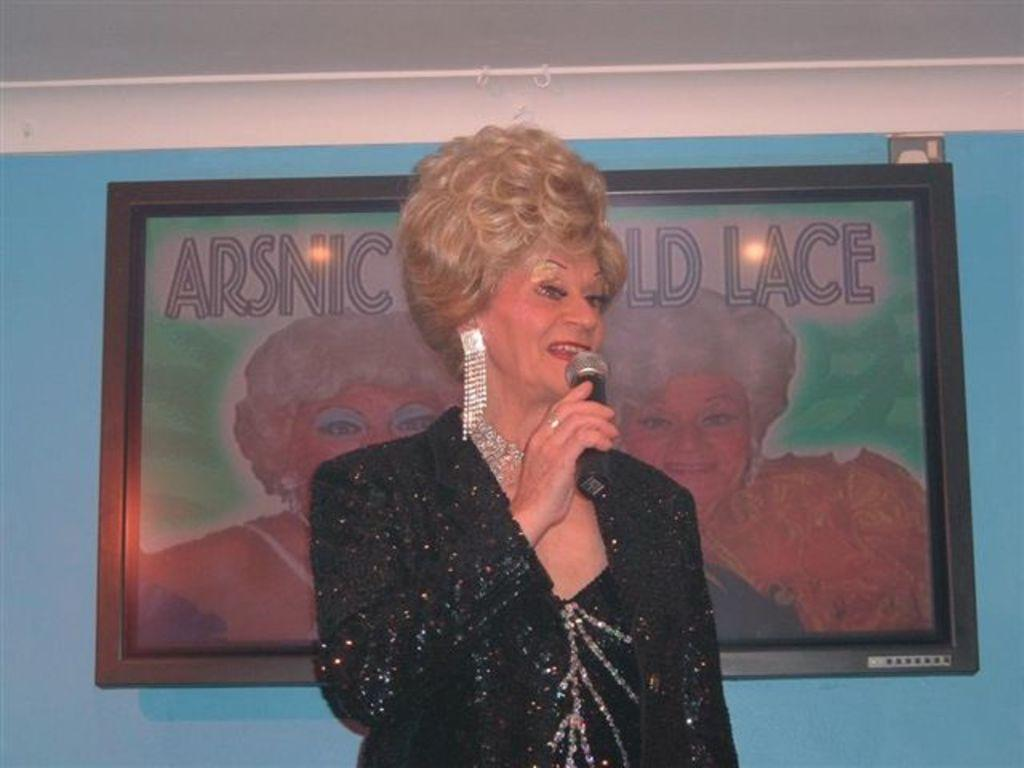Who is the main subject in the image? There is a lady in the image. What is the lady doing in the image? The lady is speaking into a microphone. What can be seen on the wall in the image? There is a photo frame on the wall. What color is the wall in the image? The wall in the image is blue. How many dogs are present in the image? There are no dogs present in the image. What type of fuel is being used by the lady in the image? The lady is speaking into a microphone, and there is no mention of fuel in the image. 